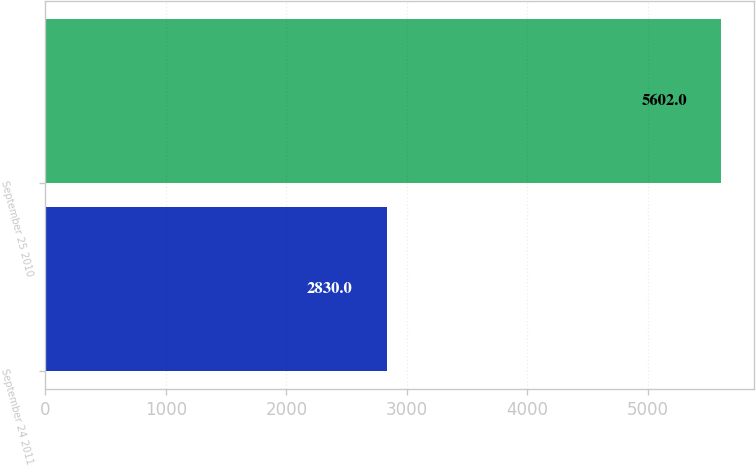Convert chart to OTSL. <chart><loc_0><loc_0><loc_500><loc_500><bar_chart><fcel>September 24 2011<fcel>September 25 2010<nl><fcel>2830<fcel>5602<nl></chart> 